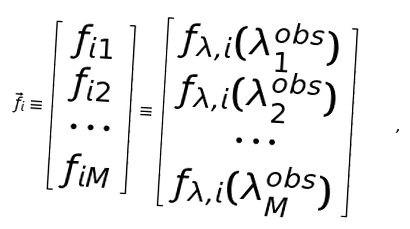<formula> <loc_0><loc_0><loc_500><loc_500>\vec { f } _ { i } \equiv \left [ \begin{array} { c } f _ { i 1 } \\ f _ { i 2 } \\ \cdots \\ f _ { i M } \end{array} \right ] \equiv \left [ \begin{array} { c } f _ { \lambda , i } ( \lambda ^ { o b s } _ { 1 } ) \\ f _ { \lambda , i } ( \lambda ^ { o b s } _ { 2 } ) \\ \cdots \\ f _ { \lambda , i } ( \lambda ^ { o b s } _ { M } ) \end{array} \right ] \quad ,</formula> 